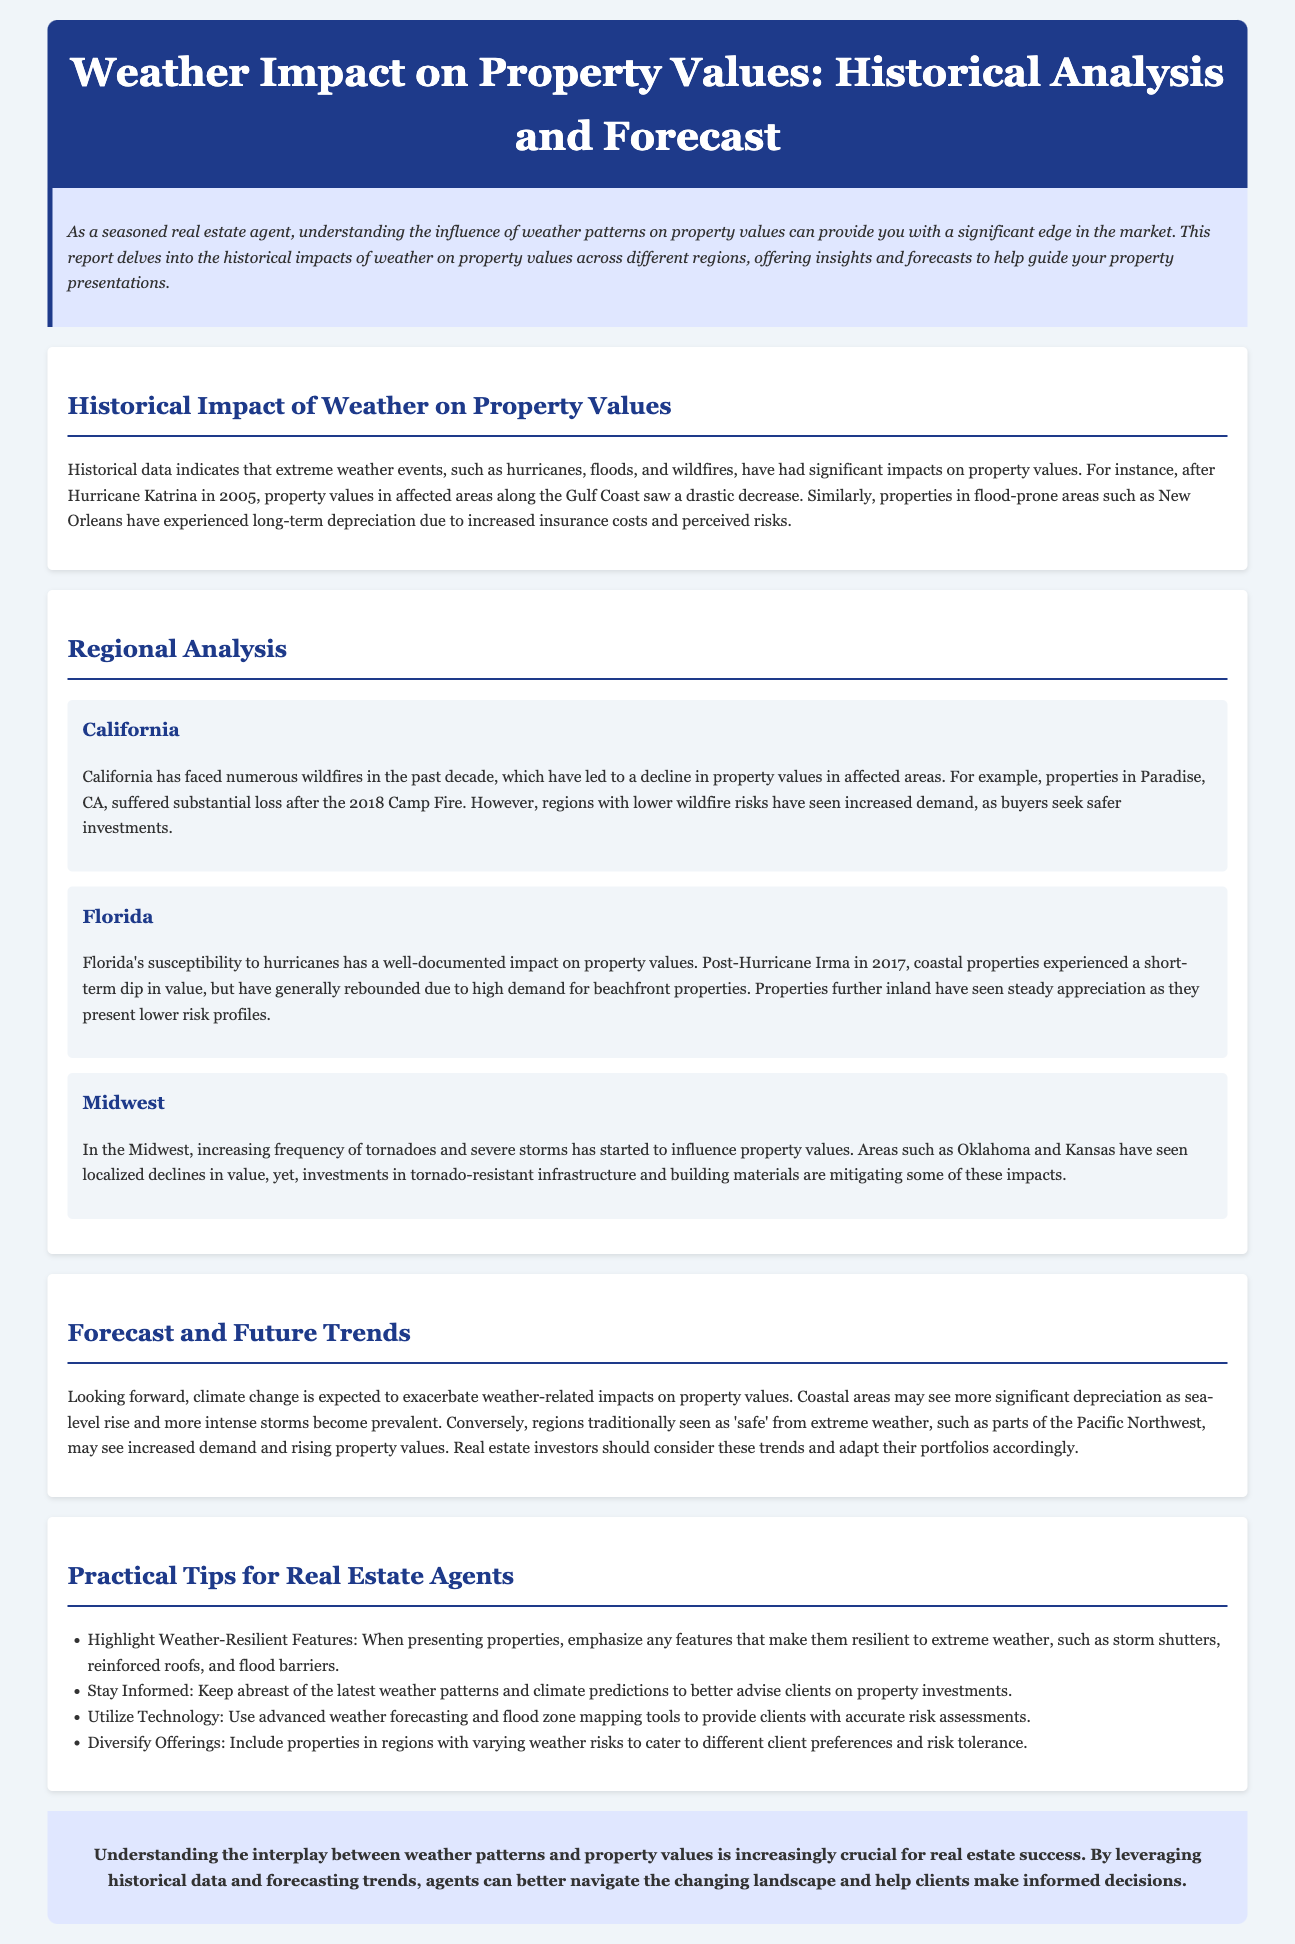What major weather events impacted property values historically? Historical impacts include hurricanes, floods, and wildfires affecting property values.
Answer: Hurricanes, floods, wildfires What region suffered substantial property loss after the 2018 Camp Fire? Paradise, CA experienced a substantial loss in property values following the 2018 Camp Fire.
Answer: Paradise, CA What were the effects of Hurricane Irma on Florida's coastal properties? Coastal properties experienced a short-term dip in value post-Hurricane Irma but generally rebounded due to high demand.
Answer: Short-term dip, rebounded Which Midwest states have seen localized declines in property values due to tornadoes? Oklahoma and Kansas have experienced localized declines in property values due to increasing tornado frequency.
Answer: Oklahoma, Kansas What is anticipated to exacerbate weather-related impacts on property values? Climate change is expected to intensify weather-related impacts on property values.
Answer: Climate change What feature should real estate agents highlight when presenting properties? Agents should emphasize any features that make properties resilient to extreme weather.
Answer: Weather-resilient features How many tips are provided for real estate agents? The document lists four practical tips for real estate agents regarding property presentations considering weather impact.
Answer: Four What type of areas may see increased demand due to lower weather risks? Regions traditionally seen as 'safe' from extreme weather may see increased demand and rising property values.
Answer: Safe regions Which tool is recommended for accurate risk assessments? Advanced weather forecasting and flood zone mapping tools are recommended for accurate risk assessments.
Answer: Mapping tools 